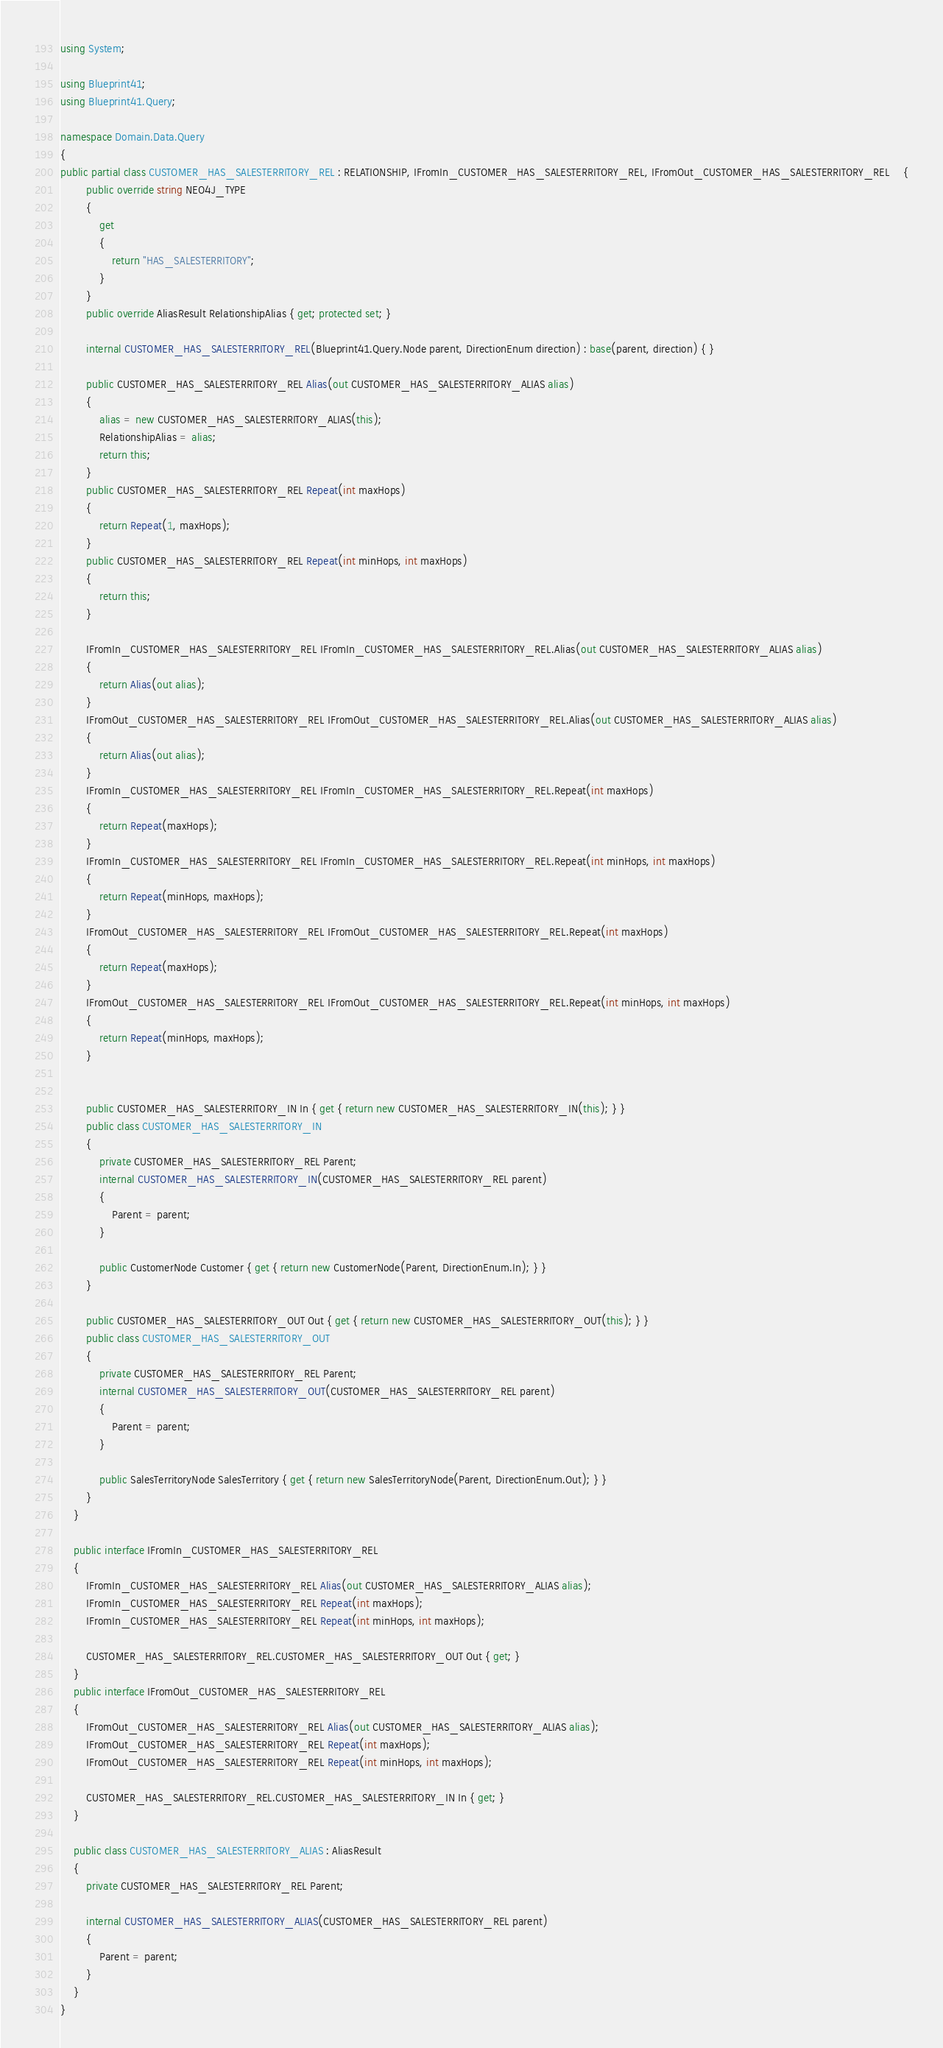<code> <loc_0><loc_0><loc_500><loc_500><_C#_>using System;

using Blueprint41;
using Blueprint41.Query;

namespace Domain.Data.Query
{
public partial class CUSTOMER_HAS_SALESTERRITORY_REL : RELATIONSHIP, IFromIn_CUSTOMER_HAS_SALESTERRITORY_REL, IFromOut_CUSTOMER_HAS_SALESTERRITORY_REL	{
        public override string NEO4J_TYPE
        {
            get
            {
                return "HAS_SALESTERRITORY";
            }
        }
        public override AliasResult RelationshipAlias { get; protected set; }
        
		internal CUSTOMER_HAS_SALESTERRITORY_REL(Blueprint41.Query.Node parent, DirectionEnum direction) : base(parent, direction) { }

		public CUSTOMER_HAS_SALESTERRITORY_REL Alias(out CUSTOMER_HAS_SALESTERRITORY_ALIAS alias)
		{
			alias = new CUSTOMER_HAS_SALESTERRITORY_ALIAS(this);
            RelationshipAlias = alias;
			return this;
		} 
		public CUSTOMER_HAS_SALESTERRITORY_REL Repeat(int maxHops)
		{
			return Repeat(1, maxHops);
		}
		public CUSTOMER_HAS_SALESTERRITORY_REL Repeat(int minHops, int maxHops)
		{
			return this;
		}

		IFromIn_CUSTOMER_HAS_SALESTERRITORY_REL IFromIn_CUSTOMER_HAS_SALESTERRITORY_REL.Alias(out CUSTOMER_HAS_SALESTERRITORY_ALIAS alias)
		{
			return Alias(out alias);
		}
		IFromOut_CUSTOMER_HAS_SALESTERRITORY_REL IFromOut_CUSTOMER_HAS_SALESTERRITORY_REL.Alias(out CUSTOMER_HAS_SALESTERRITORY_ALIAS alias)
		{
			return Alias(out alias);
		}
		IFromIn_CUSTOMER_HAS_SALESTERRITORY_REL IFromIn_CUSTOMER_HAS_SALESTERRITORY_REL.Repeat(int maxHops)
		{
			return Repeat(maxHops);
		}
		IFromIn_CUSTOMER_HAS_SALESTERRITORY_REL IFromIn_CUSTOMER_HAS_SALESTERRITORY_REL.Repeat(int minHops, int maxHops)
		{
			return Repeat(minHops, maxHops);
		}
		IFromOut_CUSTOMER_HAS_SALESTERRITORY_REL IFromOut_CUSTOMER_HAS_SALESTERRITORY_REL.Repeat(int maxHops)
		{
			return Repeat(maxHops);
		}
		IFromOut_CUSTOMER_HAS_SALESTERRITORY_REL IFromOut_CUSTOMER_HAS_SALESTERRITORY_REL.Repeat(int minHops, int maxHops)
		{
			return Repeat(minHops, maxHops);
		}


		public CUSTOMER_HAS_SALESTERRITORY_IN In { get { return new CUSTOMER_HAS_SALESTERRITORY_IN(this); } }
        public class CUSTOMER_HAS_SALESTERRITORY_IN
        {
            private CUSTOMER_HAS_SALESTERRITORY_REL Parent;
            internal CUSTOMER_HAS_SALESTERRITORY_IN(CUSTOMER_HAS_SALESTERRITORY_REL parent)
            {
                Parent = parent;
            }

			public CustomerNode Customer { get { return new CustomerNode(Parent, DirectionEnum.In); } }
        }

        public CUSTOMER_HAS_SALESTERRITORY_OUT Out { get { return new CUSTOMER_HAS_SALESTERRITORY_OUT(this); } }
        public class CUSTOMER_HAS_SALESTERRITORY_OUT
        {
            private CUSTOMER_HAS_SALESTERRITORY_REL Parent;
            internal CUSTOMER_HAS_SALESTERRITORY_OUT(CUSTOMER_HAS_SALESTERRITORY_REL parent)
            {
                Parent = parent;
            }

			public SalesTerritoryNode SalesTerritory { get { return new SalesTerritoryNode(Parent, DirectionEnum.Out); } }
        }
	}

    public interface IFromIn_CUSTOMER_HAS_SALESTERRITORY_REL
    {
		IFromIn_CUSTOMER_HAS_SALESTERRITORY_REL Alias(out CUSTOMER_HAS_SALESTERRITORY_ALIAS alias);
		IFromIn_CUSTOMER_HAS_SALESTERRITORY_REL Repeat(int maxHops);
		IFromIn_CUSTOMER_HAS_SALESTERRITORY_REL Repeat(int minHops, int maxHops);

        CUSTOMER_HAS_SALESTERRITORY_REL.CUSTOMER_HAS_SALESTERRITORY_OUT Out { get; }
    }
    public interface IFromOut_CUSTOMER_HAS_SALESTERRITORY_REL
    {
		IFromOut_CUSTOMER_HAS_SALESTERRITORY_REL Alias(out CUSTOMER_HAS_SALESTERRITORY_ALIAS alias);
		IFromOut_CUSTOMER_HAS_SALESTERRITORY_REL Repeat(int maxHops);
		IFromOut_CUSTOMER_HAS_SALESTERRITORY_REL Repeat(int minHops, int maxHops);

        CUSTOMER_HAS_SALESTERRITORY_REL.CUSTOMER_HAS_SALESTERRITORY_IN In { get; }
    }

    public class CUSTOMER_HAS_SALESTERRITORY_ALIAS : AliasResult
    {
		private CUSTOMER_HAS_SALESTERRITORY_REL Parent;

        internal CUSTOMER_HAS_SALESTERRITORY_ALIAS(CUSTOMER_HAS_SALESTERRITORY_REL parent)
        {
			Parent = parent;
        }
    }
}
</code> 